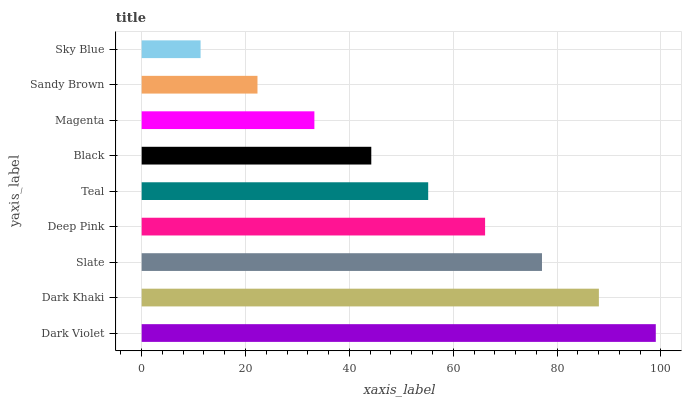Is Sky Blue the minimum?
Answer yes or no. Yes. Is Dark Violet the maximum?
Answer yes or no. Yes. Is Dark Khaki the minimum?
Answer yes or no. No. Is Dark Khaki the maximum?
Answer yes or no. No. Is Dark Violet greater than Dark Khaki?
Answer yes or no. Yes. Is Dark Khaki less than Dark Violet?
Answer yes or no. Yes. Is Dark Khaki greater than Dark Violet?
Answer yes or no. No. Is Dark Violet less than Dark Khaki?
Answer yes or no. No. Is Teal the high median?
Answer yes or no. Yes. Is Teal the low median?
Answer yes or no. Yes. Is Black the high median?
Answer yes or no. No. Is Deep Pink the low median?
Answer yes or no. No. 